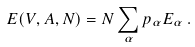<formula> <loc_0><loc_0><loc_500><loc_500>E ( V , A , N ) = N \sum _ { \alpha } p _ { \alpha } E _ { \alpha } \, .</formula> 